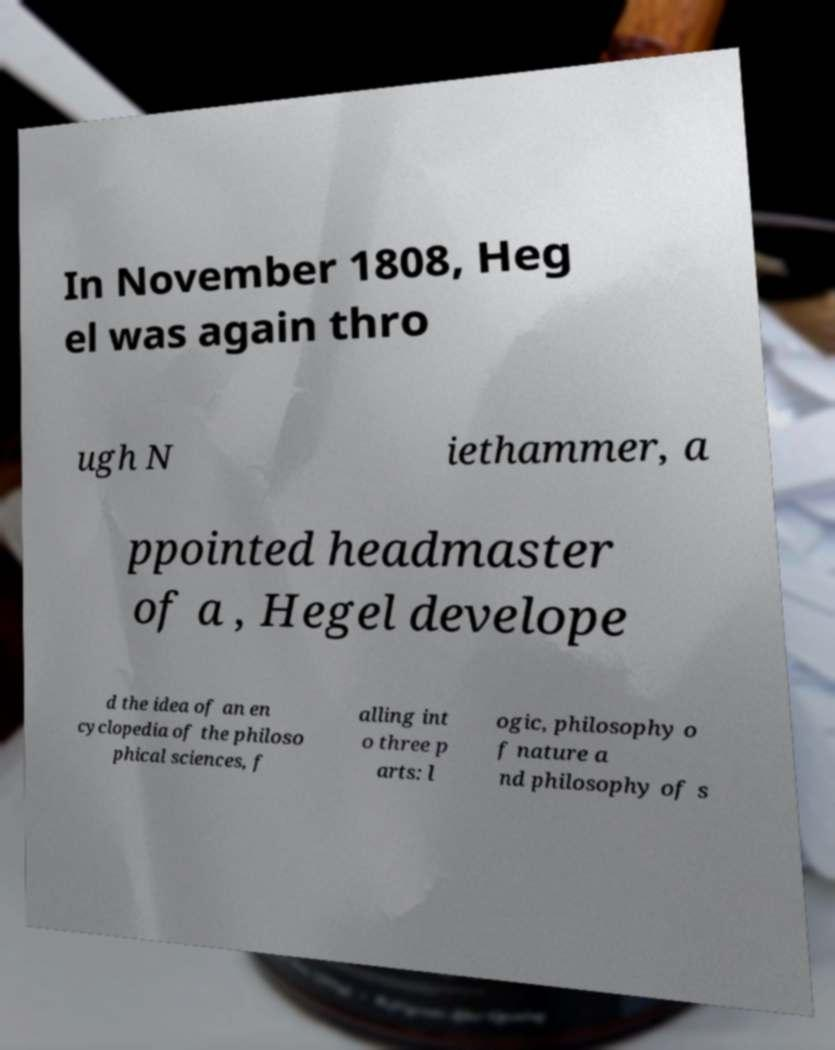I need the written content from this picture converted into text. Can you do that? In November 1808, Heg el was again thro ugh N iethammer, a ppointed headmaster of a , Hegel develope d the idea of an en cyclopedia of the philoso phical sciences, f alling int o three p arts: l ogic, philosophy o f nature a nd philosophy of s 